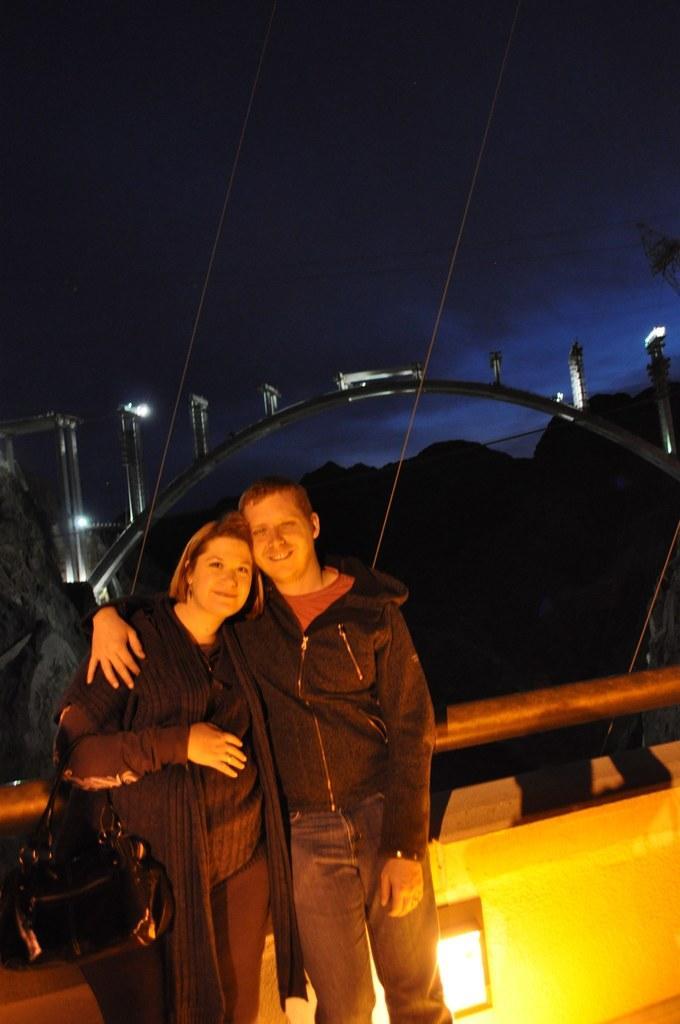In one or two sentences, can you explain what this image depicts? Here we can see a man and a woman posing to a camera and they are smiling. She is holding a bag with her hand. There are lights and an arch. There is a dark background. 